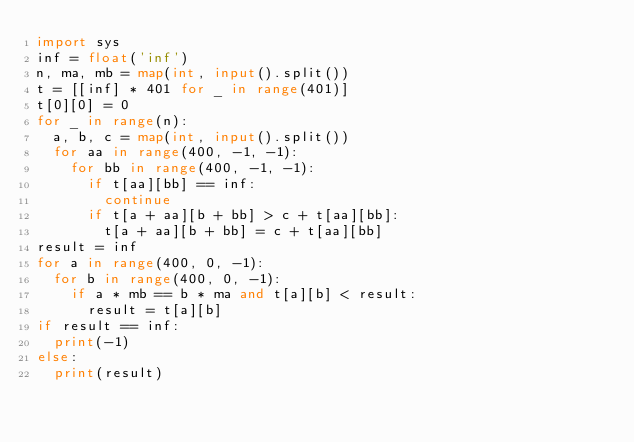<code> <loc_0><loc_0><loc_500><loc_500><_Python_>import sys
inf = float('inf')
n, ma, mb = map(int, input().split())
t = [[inf] * 401 for _ in range(401)]
t[0][0] = 0
for _ in range(n):
  a, b, c = map(int, input().split())
  for aa in range(400, -1, -1):
    for bb in range(400, -1, -1):
      if t[aa][bb] == inf:
        continue
      if t[a + aa][b + bb] > c + t[aa][bb]:
        t[a + aa][b + bb] = c + t[aa][bb]
result = inf
for a in range(400, 0, -1):
  for b in range(400, 0, -1):
    if a * mb == b * ma and t[a][b] < result:
      result = t[a][b]
if result == inf:
  print(-1)
else:
  print(result)
</code> 